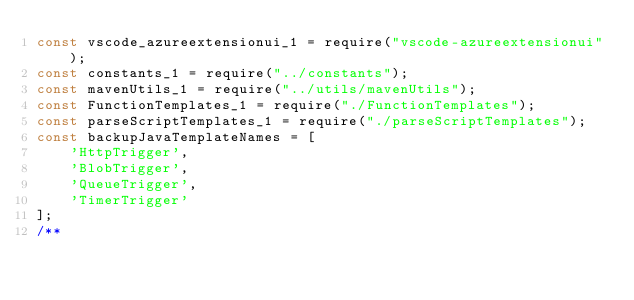Convert code to text. <code><loc_0><loc_0><loc_500><loc_500><_JavaScript_>const vscode_azureextensionui_1 = require("vscode-azureextensionui");
const constants_1 = require("../constants");
const mavenUtils_1 = require("../utils/mavenUtils");
const FunctionTemplates_1 = require("./FunctionTemplates");
const parseScriptTemplates_1 = require("./parseScriptTemplates");
const backupJavaTemplateNames = [
    'HttpTrigger',
    'BlobTrigger',
    'QueueTrigger',
    'TimerTrigger'
];
/**</code> 